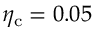<formula> <loc_0><loc_0><loc_500><loc_500>\eta _ { c } = 0 . 0 5</formula> 